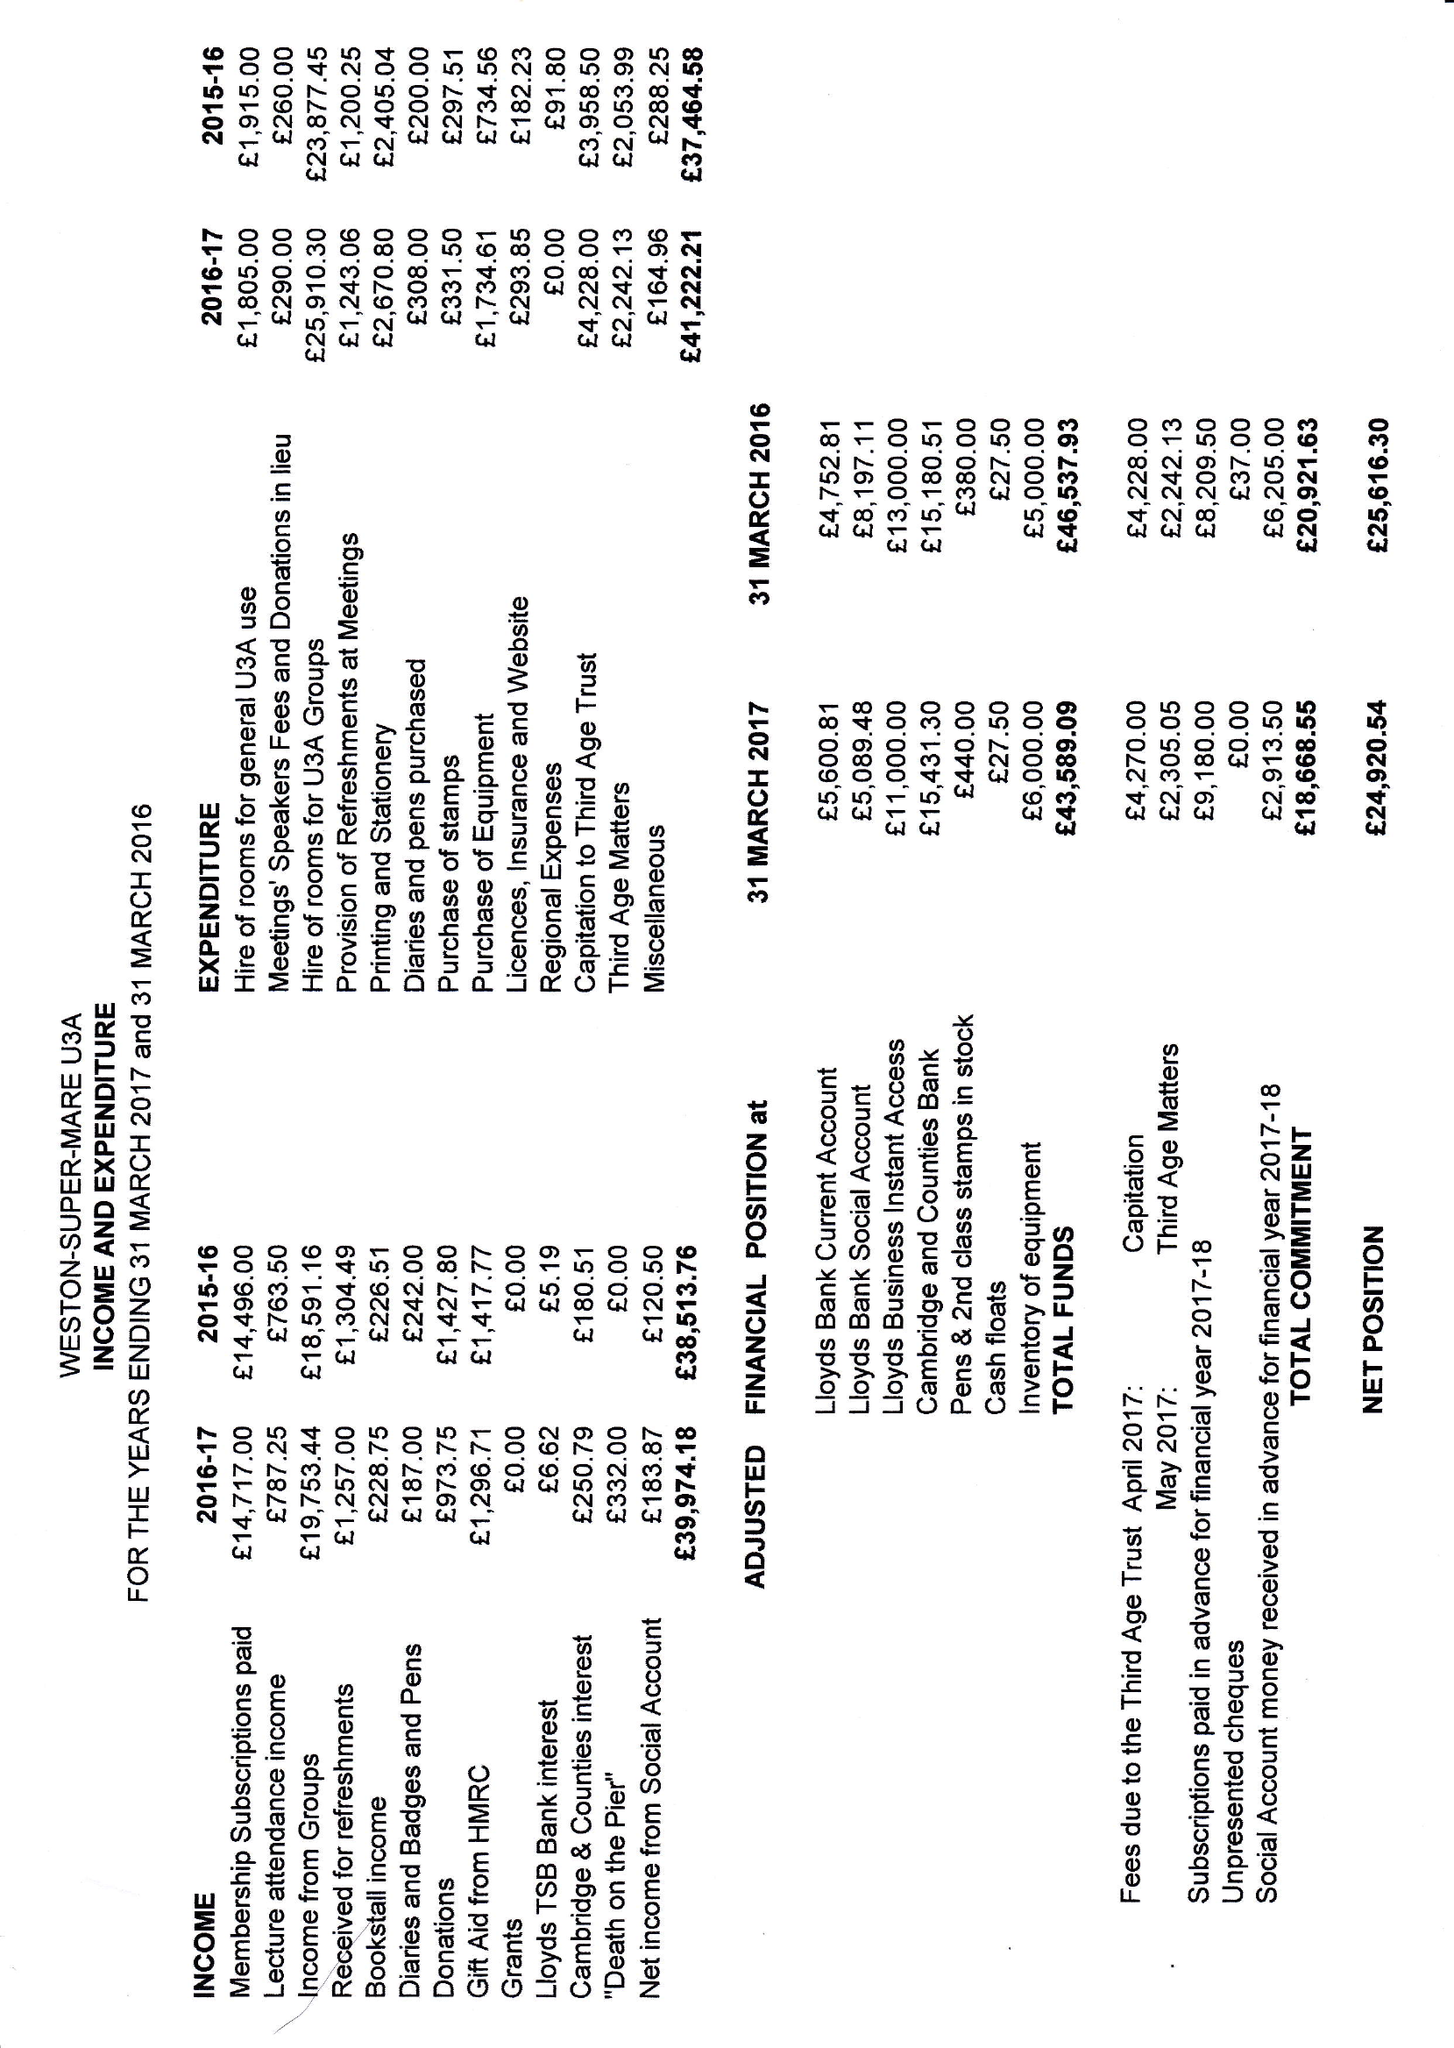What is the value for the income_annually_in_british_pounds?
Answer the question using a single word or phrase. 39974.00 